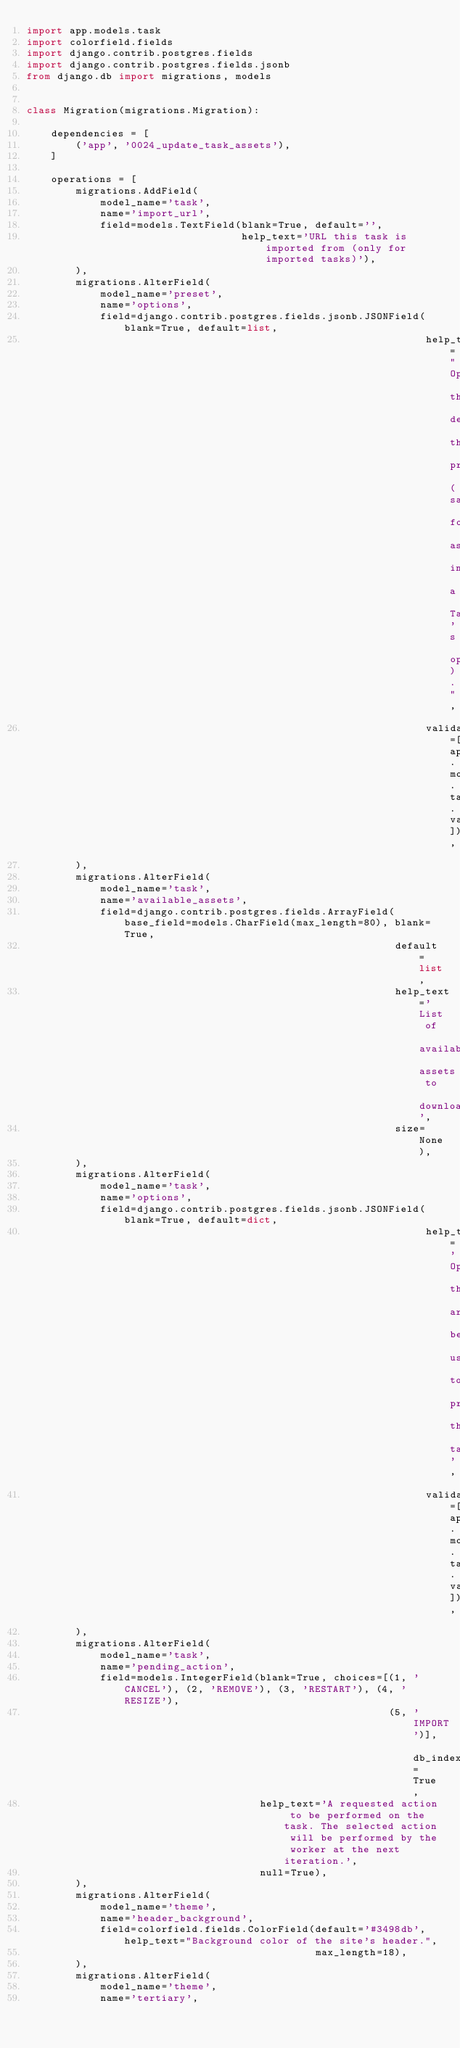<code> <loc_0><loc_0><loc_500><loc_500><_Python_>import app.models.task
import colorfield.fields
import django.contrib.postgres.fields
import django.contrib.postgres.fields.jsonb
from django.db import migrations, models


class Migration(migrations.Migration):

    dependencies = [
        ('app', '0024_update_task_assets'),
    ]

    operations = [
        migrations.AddField(
            model_name='task',
            name='import_url',
            field=models.TextField(blank=True, default='',
                                   help_text='URL this task is imported from (only for imported tasks)'),
        ),
        migrations.AlterField(
            model_name='preset',
            name='options',
            field=django.contrib.postgres.fields.jsonb.JSONField(blank=True, default=list,
                                                                 help_text="Options that define this preset (same format as in a Task's options).",
                                                                 validators=[app.models.task.validate_task_options]),
        ),
        migrations.AlterField(
            model_name='task',
            name='available_assets',
            field=django.contrib.postgres.fields.ArrayField(base_field=models.CharField(max_length=80), blank=True,
                                                            default=list,
                                                            help_text='List of available assets to download',
                                                            size=None),
        ),
        migrations.AlterField(
            model_name='task',
            name='options',
            field=django.contrib.postgres.fields.jsonb.JSONField(blank=True, default=dict,
                                                                 help_text='Options that are being used to process this task',
                                                                 validators=[app.models.task.validate_task_options]),
        ),
        migrations.AlterField(
            model_name='task',
            name='pending_action',
            field=models.IntegerField(blank=True, choices=[(1, 'CANCEL'), (2, 'REMOVE'), (3, 'RESTART'), (4, 'RESIZE'),
                                                           (5, 'IMPORT')], db_index=True,
                                      help_text='A requested action to be performed on the task. The selected action will be performed by the worker at the next iteration.',
                                      null=True),
        ),
        migrations.AlterField(
            model_name='theme',
            name='header_background',
            field=colorfield.fields.ColorField(default='#3498db', help_text="Background color of the site's header.",
                                               max_length=18),
        ),
        migrations.AlterField(
            model_name='theme',
            name='tertiary',</code> 